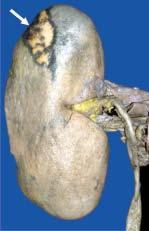what is slightly depressed on the surface?
Answer the question using a single word or phrase. The wedge-shaped infarct 